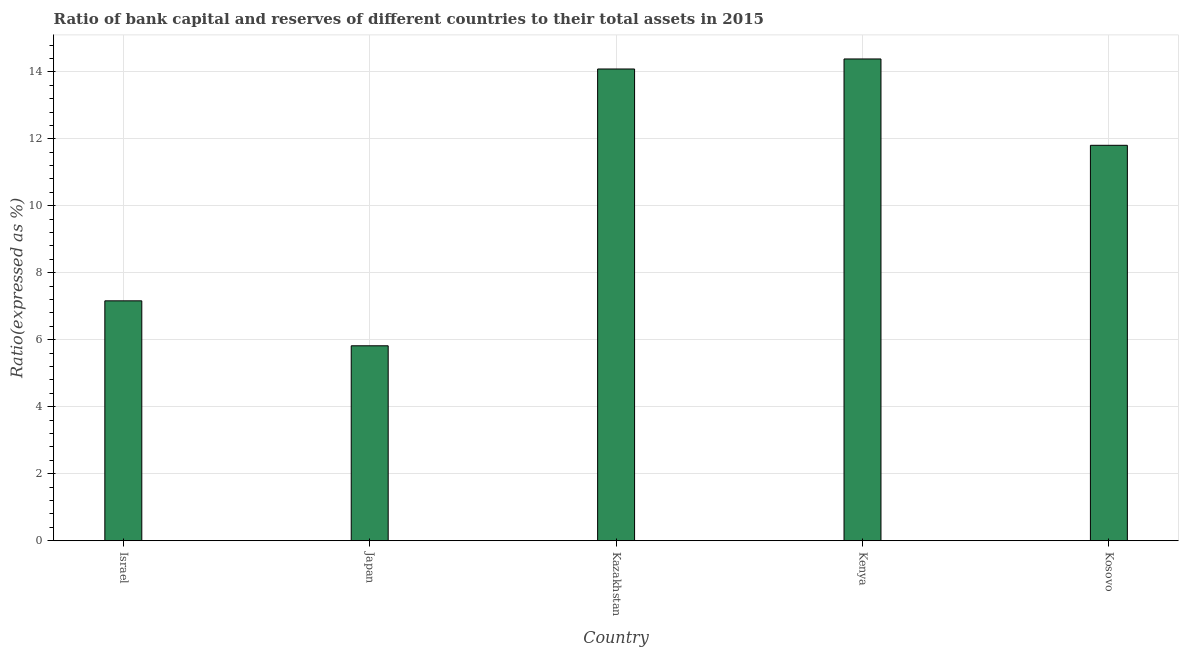Does the graph contain any zero values?
Offer a very short reply. No. What is the title of the graph?
Your answer should be compact. Ratio of bank capital and reserves of different countries to their total assets in 2015. What is the label or title of the X-axis?
Your answer should be very brief. Country. What is the label or title of the Y-axis?
Offer a terse response. Ratio(expressed as %). What is the bank capital to assets ratio in Kazakhstan?
Your answer should be compact. 14.08. Across all countries, what is the maximum bank capital to assets ratio?
Your answer should be compact. 14.38. Across all countries, what is the minimum bank capital to assets ratio?
Give a very brief answer. 5.82. In which country was the bank capital to assets ratio maximum?
Offer a terse response. Kenya. In which country was the bank capital to assets ratio minimum?
Offer a very short reply. Japan. What is the sum of the bank capital to assets ratio?
Offer a terse response. 53.26. What is the difference between the bank capital to assets ratio in Israel and Japan?
Offer a terse response. 1.34. What is the average bank capital to assets ratio per country?
Your answer should be compact. 10.65. What is the median bank capital to assets ratio?
Provide a short and direct response. 11.81. In how many countries, is the bank capital to assets ratio greater than 4 %?
Provide a short and direct response. 5. What is the ratio of the bank capital to assets ratio in Israel to that in Kosovo?
Your response must be concise. 0.61. Is the bank capital to assets ratio in Japan less than that in Kenya?
Offer a very short reply. Yes. Is the difference between the bank capital to assets ratio in Kazakhstan and Kosovo greater than the difference between any two countries?
Your answer should be compact. No. What is the difference between the highest and the second highest bank capital to assets ratio?
Keep it short and to the point. 0.3. Is the sum of the bank capital to assets ratio in Kenya and Kosovo greater than the maximum bank capital to assets ratio across all countries?
Provide a short and direct response. Yes. What is the difference between the highest and the lowest bank capital to assets ratio?
Your answer should be compact. 8.56. In how many countries, is the bank capital to assets ratio greater than the average bank capital to assets ratio taken over all countries?
Your answer should be very brief. 3. Are all the bars in the graph horizontal?
Give a very brief answer. No. What is the difference between two consecutive major ticks on the Y-axis?
Offer a very short reply. 2. Are the values on the major ticks of Y-axis written in scientific E-notation?
Your response must be concise. No. What is the Ratio(expressed as %) in Israel?
Keep it short and to the point. 7.16. What is the Ratio(expressed as %) of Japan?
Provide a succinct answer. 5.82. What is the Ratio(expressed as %) in Kazakhstan?
Your answer should be compact. 14.08. What is the Ratio(expressed as %) in Kenya?
Give a very brief answer. 14.38. What is the Ratio(expressed as %) of Kosovo?
Your answer should be compact. 11.81. What is the difference between the Ratio(expressed as %) in Israel and Japan?
Offer a very short reply. 1.34. What is the difference between the Ratio(expressed as %) in Israel and Kazakhstan?
Give a very brief answer. -6.92. What is the difference between the Ratio(expressed as %) in Israel and Kenya?
Provide a succinct answer. -7.22. What is the difference between the Ratio(expressed as %) in Israel and Kosovo?
Offer a terse response. -4.64. What is the difference between the Ratio(expressed as %) in Japan and Kazakhstan?
Offer a very short reply. -8.26. What is the difference between the Ratio(expressed as %) in Japan and Kenya?
Your answer should be very brief. -8.56. What is the difference between the Ratio(expressed as %) in Japan and Kosovo?
Ensure brevity in your answer.  -5.99. What is the difference between the Ratio(expressed as %) in Kazakhstan and Kenya?
Make the answer very short. -0.3. What is the difference between the Ratio(expressed as %) in Kazakhstan and Kosovo?
Your response must be concise. 2.28. What is the difference between the Ratio(expressed as %) in Kenya and Kosovo?
Your answer should be compact. 2.58. What is the ratio of the Ratio(expressed as %) in Israel to that in Japan?
Make the answer very short. 1.23. What is the ratio of the Ratio(expressed as %) in Israel to that in Kazakhstan?
Keep it short and to the point. 0.51. What is the ratio of the Ratio(expressed as %) in Israel to that in Kenya?
Keep it short and to the point. 0.5. What is the ratio of the Ratio(expressed as %) in Israel to that in Kosovo?
Offer a terse response. 0.61. What is the ratio of the Ratio(expressed as %) in Japan to that in Kazakhstan?
Provide a short and direct response. 0.41. What is the ratio of the Ratio(expressed as %) in Japan to that in Kenya?
Your answer should be compact. 0.41. What is the ratio of the Ratio(expressed as %) in Japan to that in Kosovo?
Provide a succinct answer. 0.49. What is the ratio of the Ratio(expressed as %) in Kazakhstan to that in Kosovo?
Offer a very short reply. 1.19. What is the ratio of the Ratio(expressed as %) in Kenya to that in Kosovo?
Offer a terse response. 1.22. 